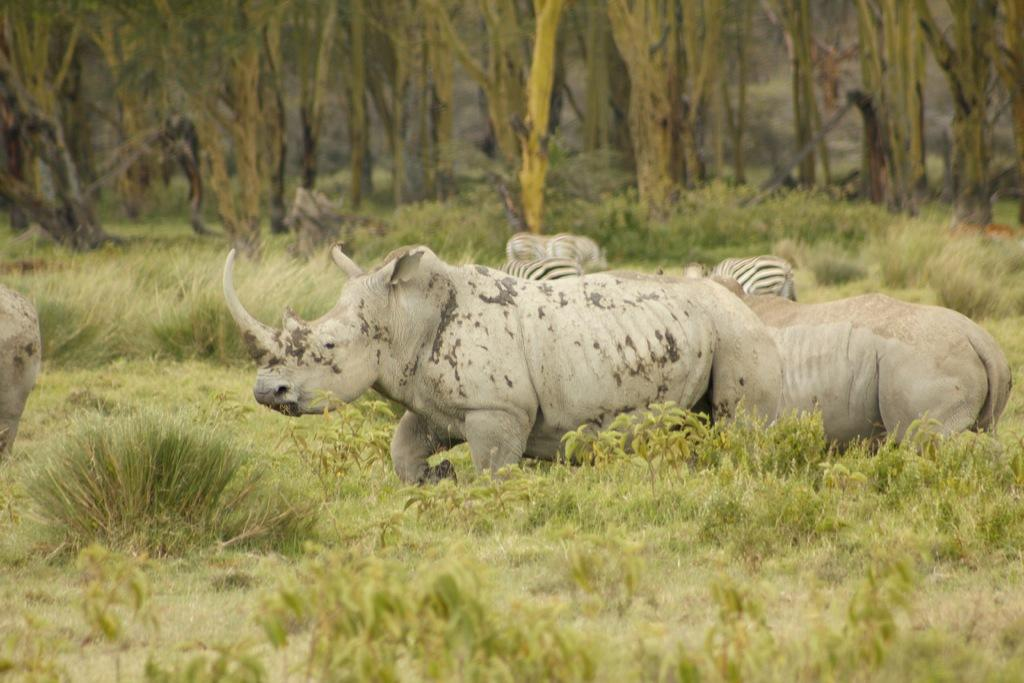What animals can be seen in the image? There are rhinos and zebras in the image. What is on the ground in the image? There is grass and plants on the ground in the image. What can be seen in the background of the image? There are trees in the background of the image. Can you see a man lying on a bed in the image? There is no man or bed present in the image. 